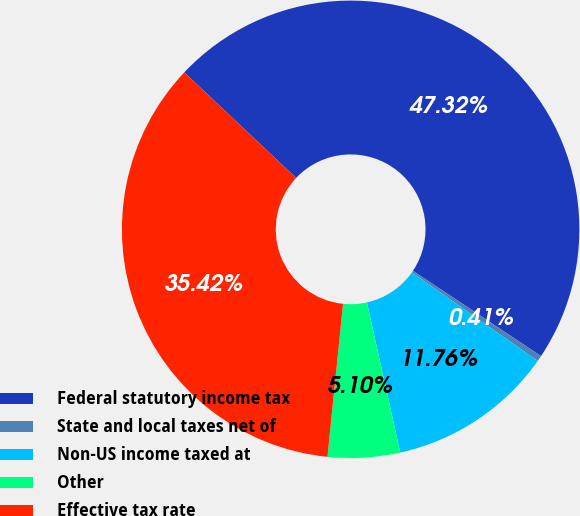<chart> <loc_0><loc_0><loc_500><loc_500><pie_chart><fcel>Federal statutory income tax<fcel>State and local taxes net of<fcel>Non-US income taxed at<fcel>Other<fcel>Effective tax rate<nl><fcel>47.32%<fcel>0.41%<fcel>11.76%<fcel>5.1%<fcel>35.42%<nl></chart> 